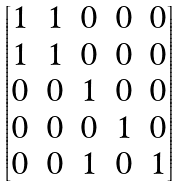Convert formula to latex. <formula><loc_0><loc_0><loc_500><loc_500>\begin{bmatrix} 1 & 1 & 0 & 0 & 0 \\ 1 & 1 & 0 & 0 & 0 \\ 0 & 0 & 1 & 0 & 0 \\ 0 & 0 & 0 & 1 & 0 \\ 0 & 0 & 1 & 0 & 1 \end{bmatrix}</formula> 